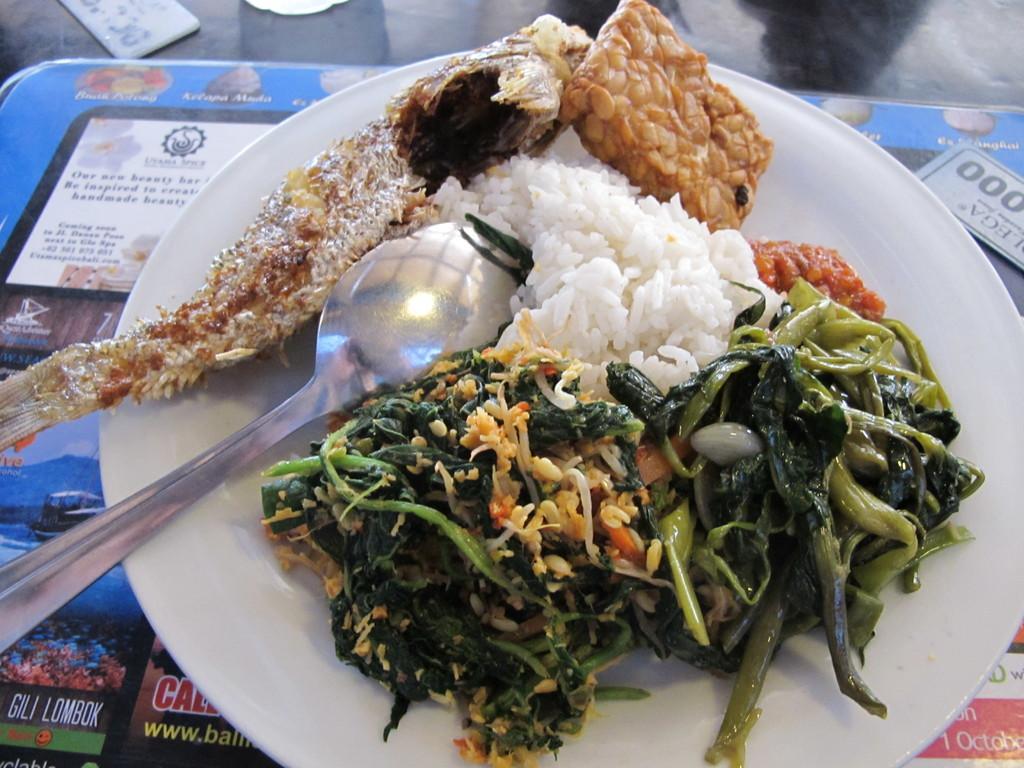Can you describe this image briefly? In the picture I can see a plate on the table. I can see rice, curries and a spoon on the plate. 